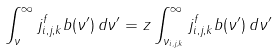Convert formula to latex. <formula><loc_0><loc_0><loc_500><loc_500>\int _ { \nu } ^ { \infty } j _ { i , j , k } ^ { f } b ( \nu ^ { \prime } ) \, d \nu ^ { \prime } = z \int _ { \nu _ { i , j , k } } ^ { \infty } j _ { i , j , k } ^ { f } b ( \nu ^ { \prime } ) \, d \nu ^ { \prime }</formula> 